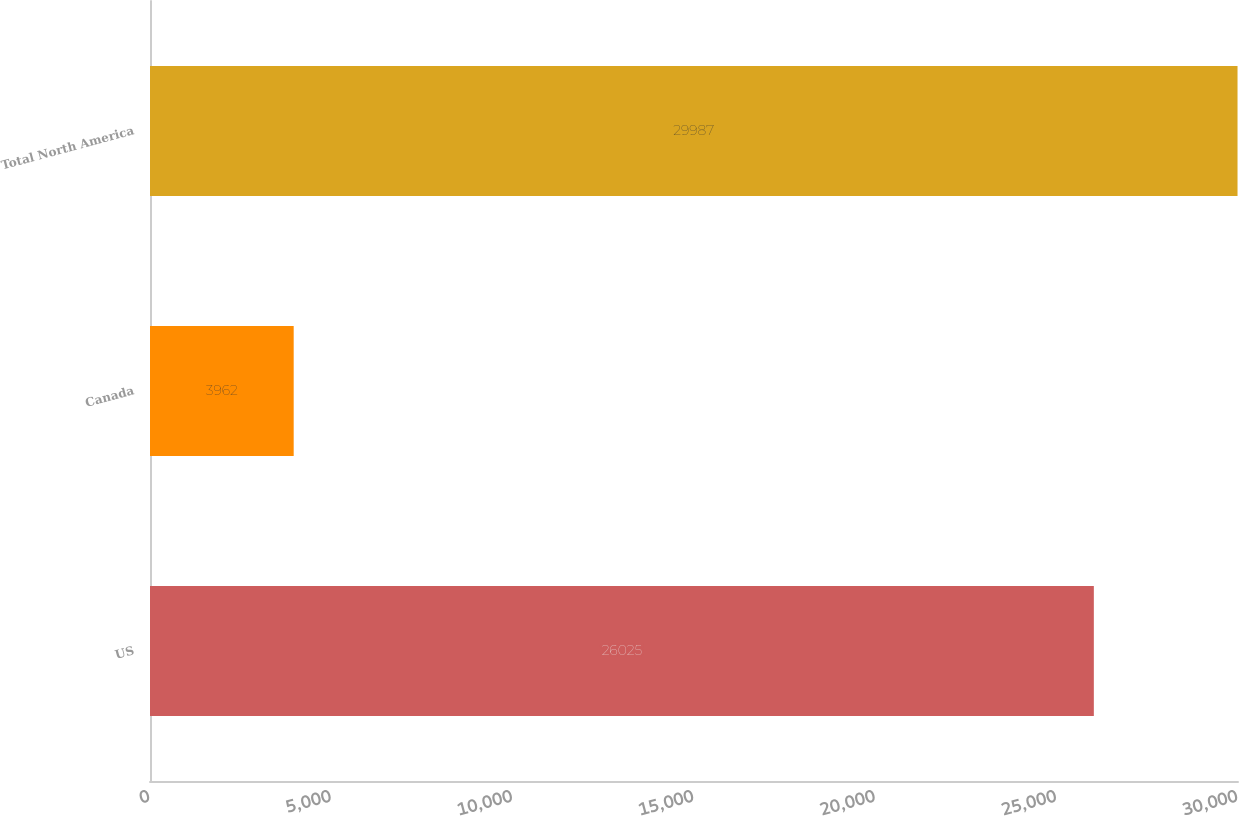Convert chart. <chart><loc_0><loc_0><loc_500><loc_500><bar_chart><fcel>US<fcel>Canada<fcel>Total North America<nl><fcel>26025<fcel>3962<fcel>29987<nl></chart> 